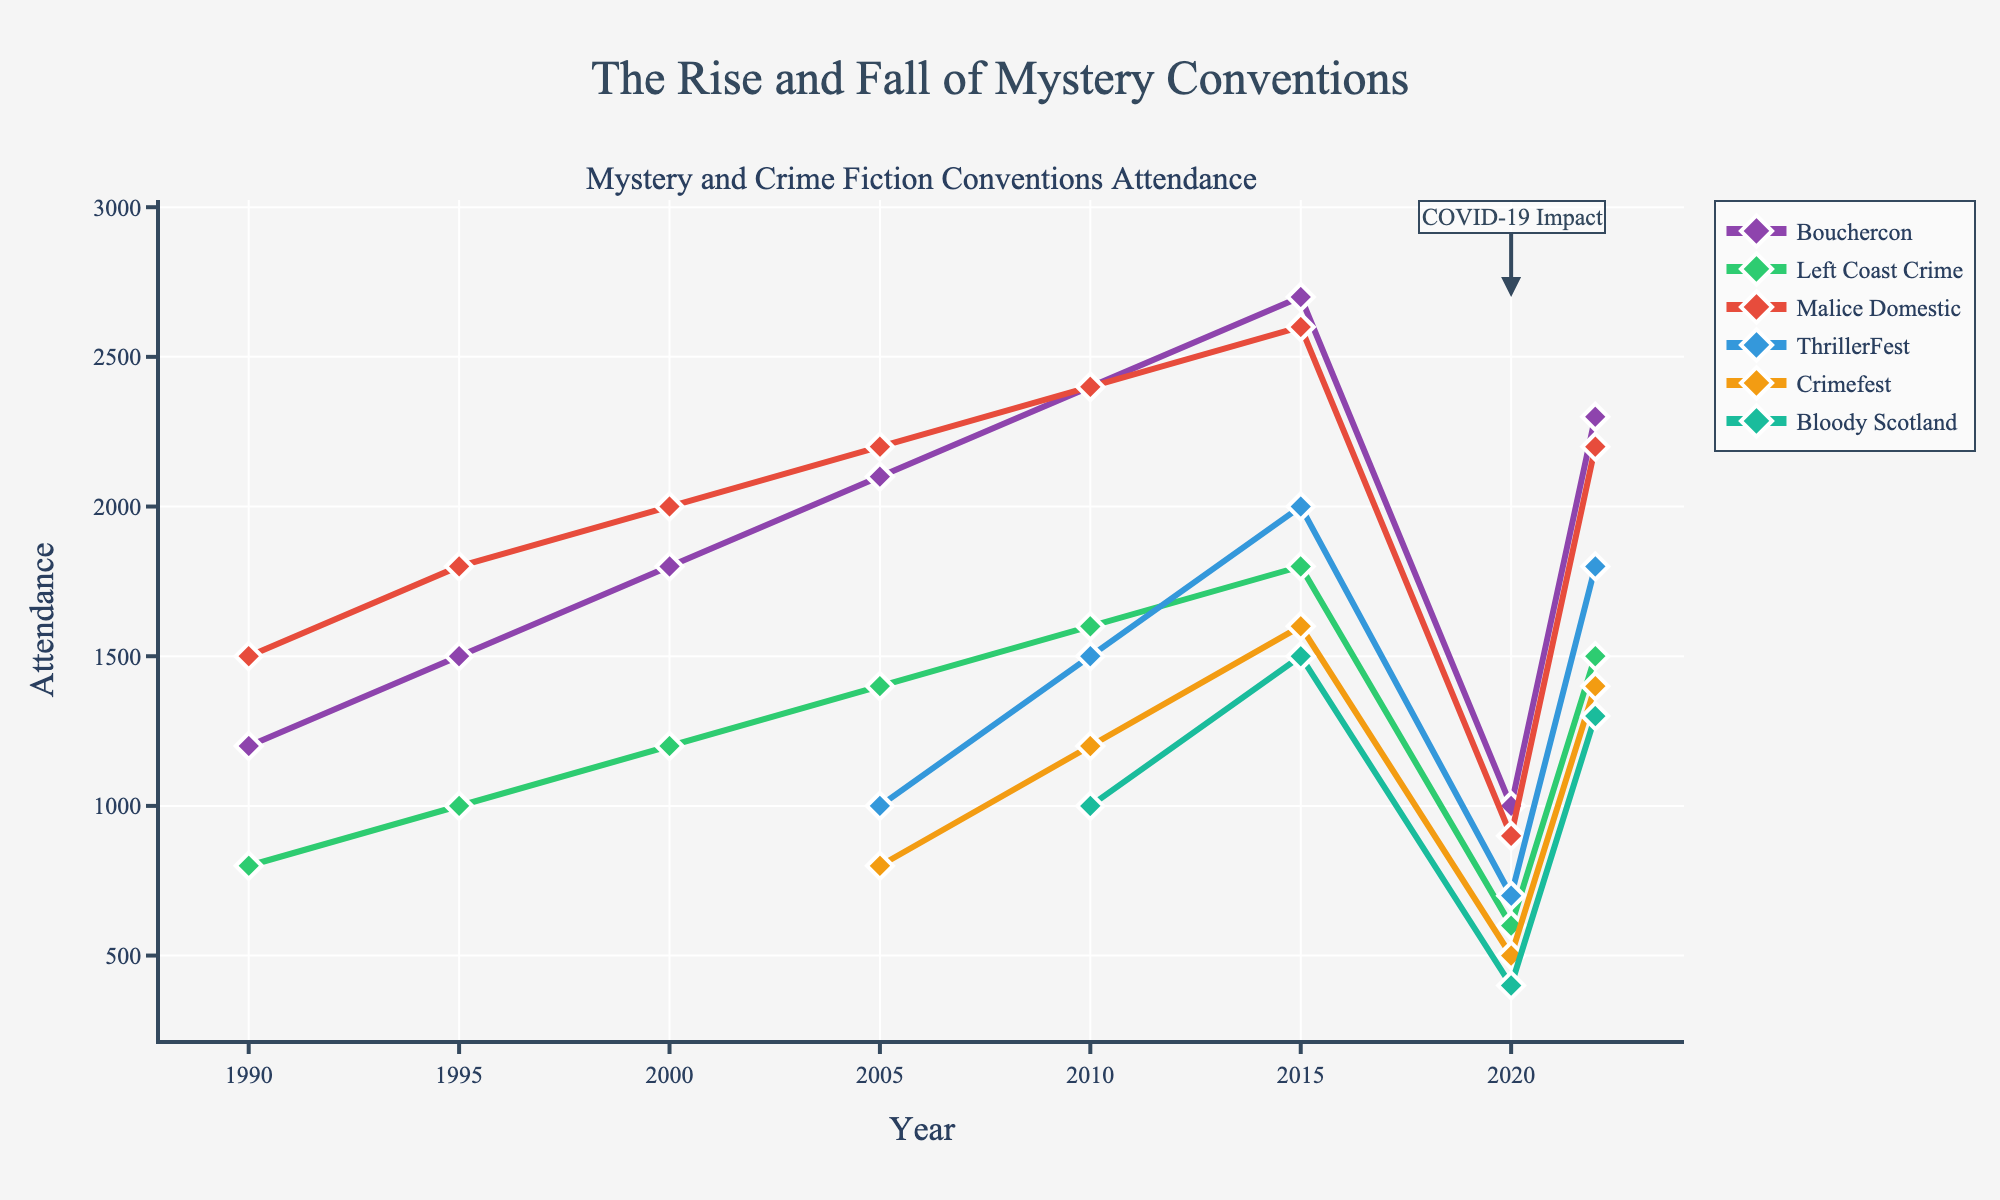What's the overall trend for Bouchercon's attendance between 1990 and 2022? To determine the overall trend, look at the starting attendance in 1990 and the ending attendance in 2022. Bouchercon's attendance increases from 1200 in 1990 to 2300 in 2022, indicating an upward trend despite a dip in 2020.
Answer: Upward trend Which convention had the lowest attendance in 2020? Based on the plot, the convention with the lowest attendance is identified by the lowest point in 2020. Crimefest shows the lowest attendance of 500 in 2020.
Answer: Crimefest How did the attendance of Malice Domestic in 2010 compare to its attendance in 2020? Malice Domestic had an attendance of 2400 in 2010 and 900 in 2020. The difference is 2400 - 900 = 1500, indicating a significant drop.
Answer: It dropped by 1500 What year had the highest attendance for Bloody Scotland? Find the highest point along the Bloody Scotland line. In 2015, Bloody Scotland reached its peak attendance of 1500.
Answer: 2015 Did any conventions experience growth in every recorded interval from 1990 to 2022? Check each convention's attendance data for continuous growth in each period. Bouchercon shows consistent growth from 1990 to 2015, with a dip in 2020, failing to meet the criteria of continuous growth. No convention has uninterrupted growth across all intervals.
Answer: No Which convention had a greater attendance in 2005: Bouchercon or Left Coast Crime? Compare the attendance numbers for the two conventions in 2005. Bouchercon had 2100, and Left Coast Crime had 1400.
Answer: Bouchercon What was the total combined attendance of all conventions in 2010? Sum the attendance figures for all conventions in 2010: 2400 (Bouchercon) + 1600 (Left Coast Crime) + 2400 (Malice Domestic) + 1500 (ThrillerFest) + 1200 (Crimefest) + 1000 (Bloody Scotland) = 10100.
Answer: 10100 Which convention showed the most significant decline from its peak attendance by 2020? Identify the peak attendance for each convention and compare it to their 2020 attendance to find the largest decline. Malice Domestic peaked at 2600 in 2015 and dropped to 900 in 2020, a difference of 1700, the largest drop among the conventions.
Answer: Malice Domestic What's the average attendance for Left Coast Crime from 1990 to 2022? Sum the attendance of Left Coast Crime for all recorded years: 800 (1990) + 1000 (1995) + 1200 (2000) + 1400 (2005) + 1600 (2010) + 1800 (2015) + 600 (2020) + 1500 (2022) = 9900. Divide by the number of years (8): 9900 / 8 = 1237.5.
Answer: 1237.5 What is the range of attendance for ThrillerFest from 2005 to 2022? Determine the maximum and minimum attendance values for ThrillerFest within the given years. The highest attendance was 2000 in 2015, and the lowest was 700 in 2020. The range is 2000 - 700 = 1300.
Answer: 1300 